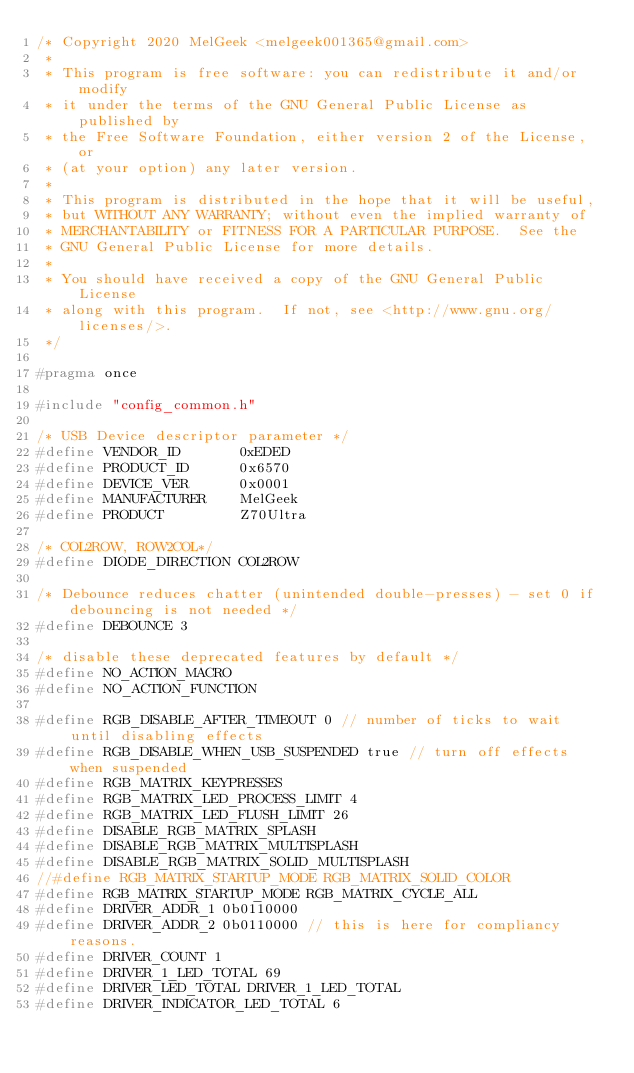<code> <loc_0><loc_0><loc_500><loc_500><_C_>/* Copyright 2020 MelGeek <melgeek001365@gmail.com>
 *
 * This program is free software: you can redistribute it and/or modify
 * it under the terms of the GNU General Public License as published by
 * the Free Software Foundation, either version 2 of the License, or
 * (at your option) any later version.
 *
 * This program is distributed in the hope that it will be useful,
 * but WITHOUT ANY WARRANTY; without even the implied warranty of
 * MERCHANTABILITY or FITNESS FOR A PARTICULAR PURPOSE.  See the
 * GNU General Public License for more details.
 *
 * You should have received a copy of the GNU General Public License
 * along with this program.  If not, see <http://www.gnu.org/licenses/>.
 */

#pragma once

#include "config_common.h"

/* USB Device descriptor parameter */
#define VENDOR_ID       0xEDED
#define PRODUCT_ID      0x6570
#define DEVICE_VER      0x0001
#define MANUFACTURER    MelGeek
#define PRODUCT         Z70Ultra

/* COL2ROW, ROW2COL*/
#define DIODE_DIRECTION COL2ROW

/* Debounce reduces chatter (unintended double-presses) - set 0 if debouncing is not needed */
#define DEBOUNCE 3

/* disable these deprecated features by default */
#define NO_ACTION_MACRO
#define NO_ACTION_FUNCTION

#define RGB_DISABLE_AFTER_TIMEOUT 0 // number of ticks to wait until disabling effects
#define RGB_DISABLE_WHEN_USB_SUSPENDED true // turn off effects when suspended
#define RGB_MATRIX_KEYPRESSES
#define RGB_MATRIX_LED_PROCESS_LIMIT 4
#define RGB_MATRIX_LED_FLUSH_LIMIT 26
#define DISABLE_RGB_MATRIX_SPLASH
#define DISABLE_RGB_MATRIX_MULTISPLASH
#define DISABLE_RGB_MATRIX_SOLID_MULTISPLASH
//#define RGB_MATRIX_STARTUP_MODE RGB_MATRIX_SOLID_COLOR
#define RGB_MATRIX_STARTUP_MODE RGB_MATRIX_CYCLE_ALL
#define DRIVER_ADDR_1 0b0110000
#define DRIVER_ADDR_2 0b0110000 // this is here for compliancy reasons.
#define DRIVER_COUNT 1
#define DRIVER_1_LED_TOTAL 69
#define DRIVER_LED_TOTAL DRIVER_1_LED_TOTAL
#define DRIVER_INDICATOR_LED_TOTAL 6
</code> 